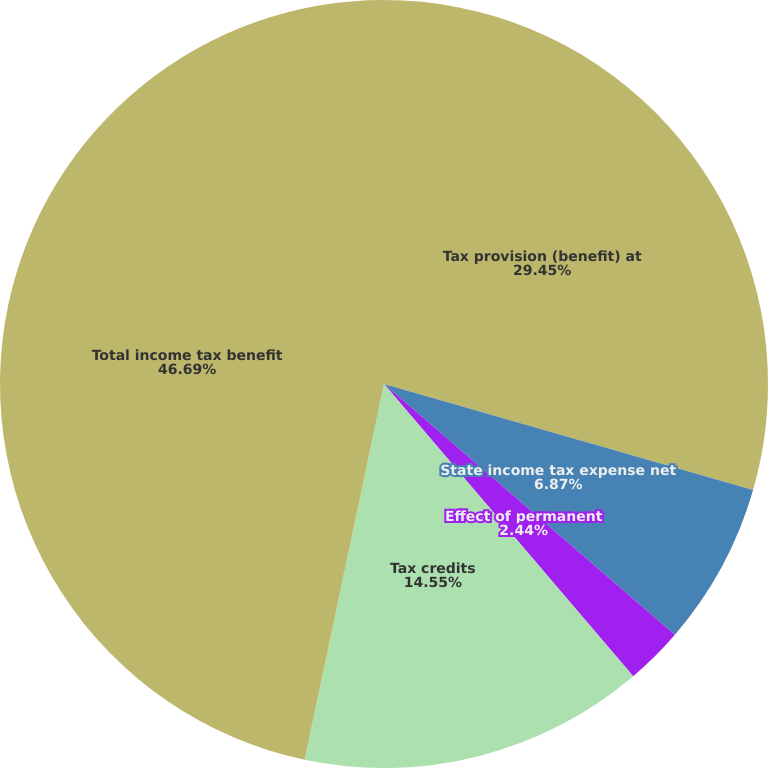<chart> <loc_0><loc_0><loc_500><loc_500><pie_chart><fcel>Tax provision (benefit) at<fcel>State income tax expense net<fcel>Effect of permanent<fcel>Tax credits<fcel>Total income tax benefit<nl><fcel>29.45%<fcel>6.87%<fcel>2.44%<fcel>14.55%<fcel>46.69%<nl></chart> 